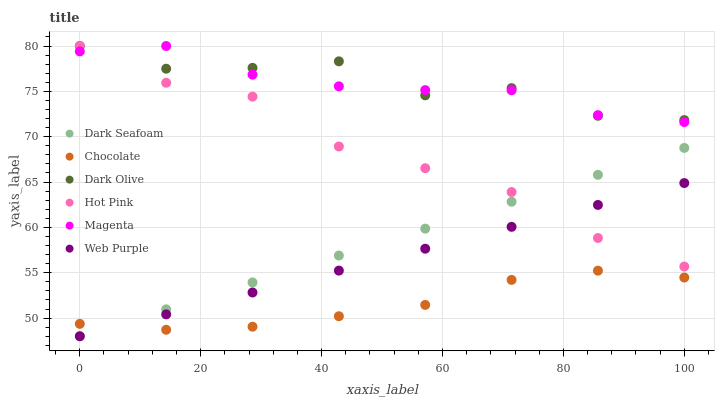Does Chocolate have the minimum area under the curve?
Answer yes or no. Yes. Does Dark Olive have the maximum area under the curve?
Answer yes or no. Yes. Does Dark Seafoam have the minimum area under the curve?
Answer yes or no. No. Does Dark Seafoam have the maximum area under the curve?
Answer yes or no. No. Is Web Purple the smoothest?
Answer yes or no. Yes. Is Dark Olive the roughest?
Answer yes or no. Yes. Is Dark Seafoam the smoothest?
Answer yes or no. No. Is Dark Seafoam the roughest?
Answer yes or no. No. Does Dark Seafoam have the lowest value?
Answer yes or no. Yes. Does Dark Olive have the lowest value?
Answer yes or no. No. Does Magenta have the highest value?
Answer yes or no. Yes. Does Dark Seafoam have the highest value?
Answer yes or no. No. Is Chocolate less than Magenta?
Answer yes or no. Yes. Is Dark Olive greater than Chocolate?
Answer yes or no. Yes. Does Web Purple intersect Hot Pink?
Answer yes or no. Yes. Is Web Purple less than Hot Pink?
Answer yes or no. No. Is Web Purple greater than Hot Pink?
Answer yes or no. No. Does Chocolate intersect Magenta?
Answer yes or no. No. 